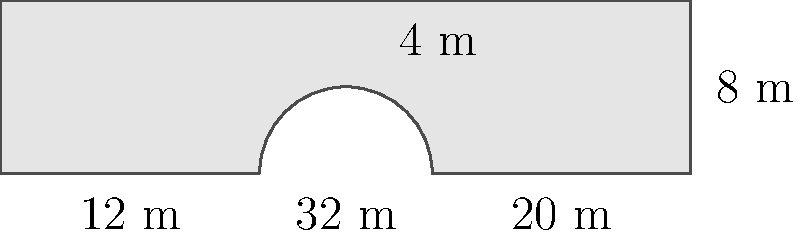For your upcoming concert at Chetham's School of Music, you need to calculate the area of a piano-shaped stage. The stage is 32 meters long and 8 meters wide at its widest point. The curved part of the stage forms a semi-circle with a radius of 4 meters. What is the total area of the stage in square meters? To calculate the area of the piano-shaped stage, we need to break it down into simpler shapes:

1. Calculate the area of the main rectangular part:
   Length = 32 m, Width = 8 m
   Area of rectangle = $32 \times 8 = 256$ m²

2. Calculate the area of the semi-circular part:
   Radius = 4 m
   Area of full circle = $\pi r^2 = \pi \times 4^2 = 16\pi$ m²
   Area of semi-circle = $\frac{1}{2} \times 16\pi = 8\pi$ m²

3. Subtract the area of the small rectangle that the semi-circle overlaps:
   Length = 8 m, Width = 4 m
   Area of small rectangle = $8 \times 4 = 32$ m²

4. Calculate the total area:
   Total Area = Area of main rectangle + Area of semi-circle - Area of small rectangle
   Total Area = $256 + 8\pi - 32 = 224 + 8\pi$ m²

5. Approximate the final answer (optional):
   $8\pi \approx 25.13$
   Total Area ≈ $224 + 25.13 = 249.13$ m²

The exact answer is $224 + 8\pi$ m², or approximately 249.13 m².
Answer: $224 + 8\pi$ m² 